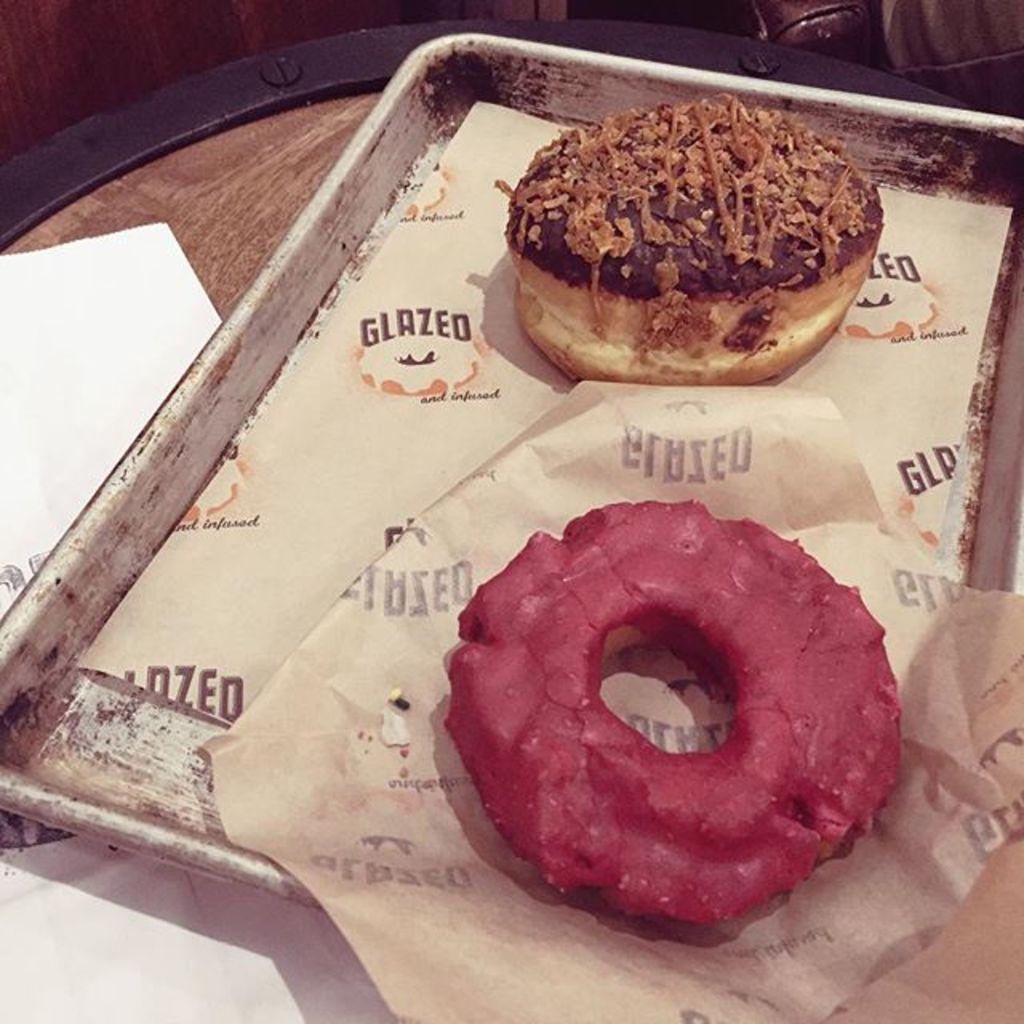Can you describe this image briefly? In this image I can see food items and papers on a tray. I can also see some other objects on a wooden surface. 